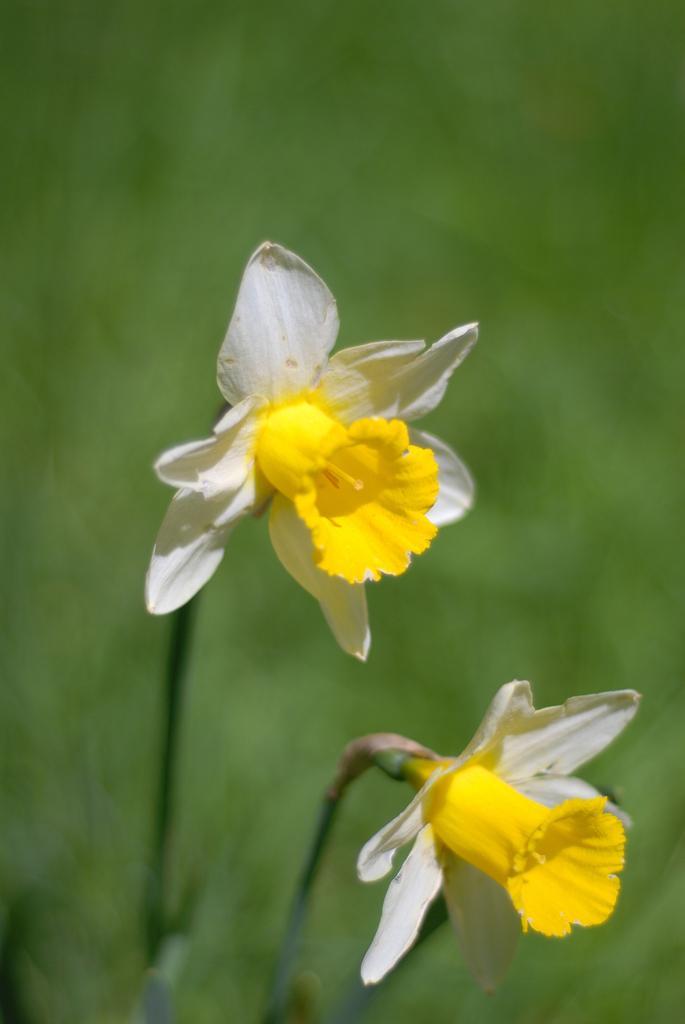Please provide a concise description of this image. In this picture we can see few flowers and blurry background. 